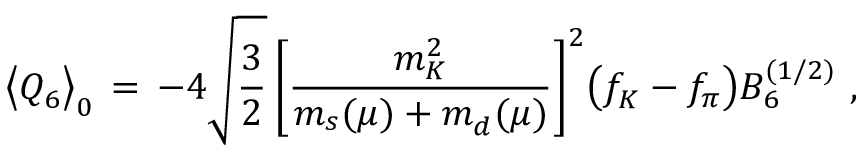<formula> <loc_0><loc_0><loc_500><loc_500>\left \langle Q _ { 6 } \right \rangle _ { 0 } \, = \, - 4 \sqrt { \frac { 3 } { 2 } } \, \left [ \frac { m _ { K } ^ { 2 } } { m _ { s } ( \mu ) + m _ { d } ( \mu ) } \right ] ^ { 2 } \left ( f _ { K } - f _ { \pi } \right ) B _ { 6 } ^ { ( 1 / 2 ) } \, ,</formula> 